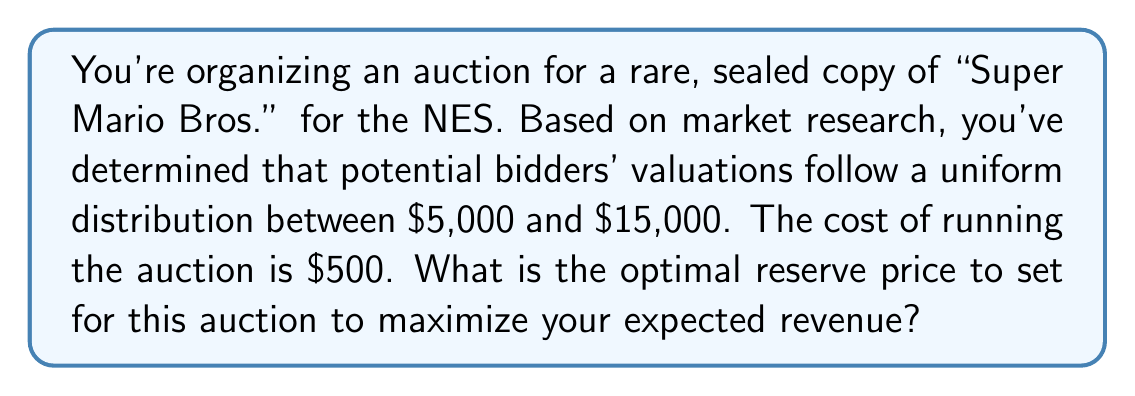Teach me how to tackle this problem. To solve this problem, we'll use the optimal reserve price formula for a uniform distribution and follow these steps:

1) For a uniform distribution between $a$ and $b$, the optimal reserve price $r^*$ is given by:

   $$r^* = \max\left(\frac{a+b}{2}, c\right)$$

   where $c$ is the seller's cost (or value to the seller).

2) In this case:
   $a = 5000$ (lower bound of distribution)
   $b = 15000$ (upper bound of distribution)
   $c = 500$ (cost of running the auction)

3) Let's calculate $\frac{a+b}{2}$:

   $$\frac{a+b}{2} = \frac{5000 + 15000}{2} = \frac{20000}{2} = 10000$$

4) Now we compare this to $c$:

   $10000 > 500$

5) Therefore, the optimal reserve price is:

   $$r^* = \max(10000, 500) = 10000$$

This reserve price maximizes the expected revenue by balancing the trade-off between a higher selling price and the risk of the item not selling. Setting the reserve price at $10,000 ensures that even if only one bidder values the item above this price, you'll still make a significant profit above your costs.
Answer: $10,000 